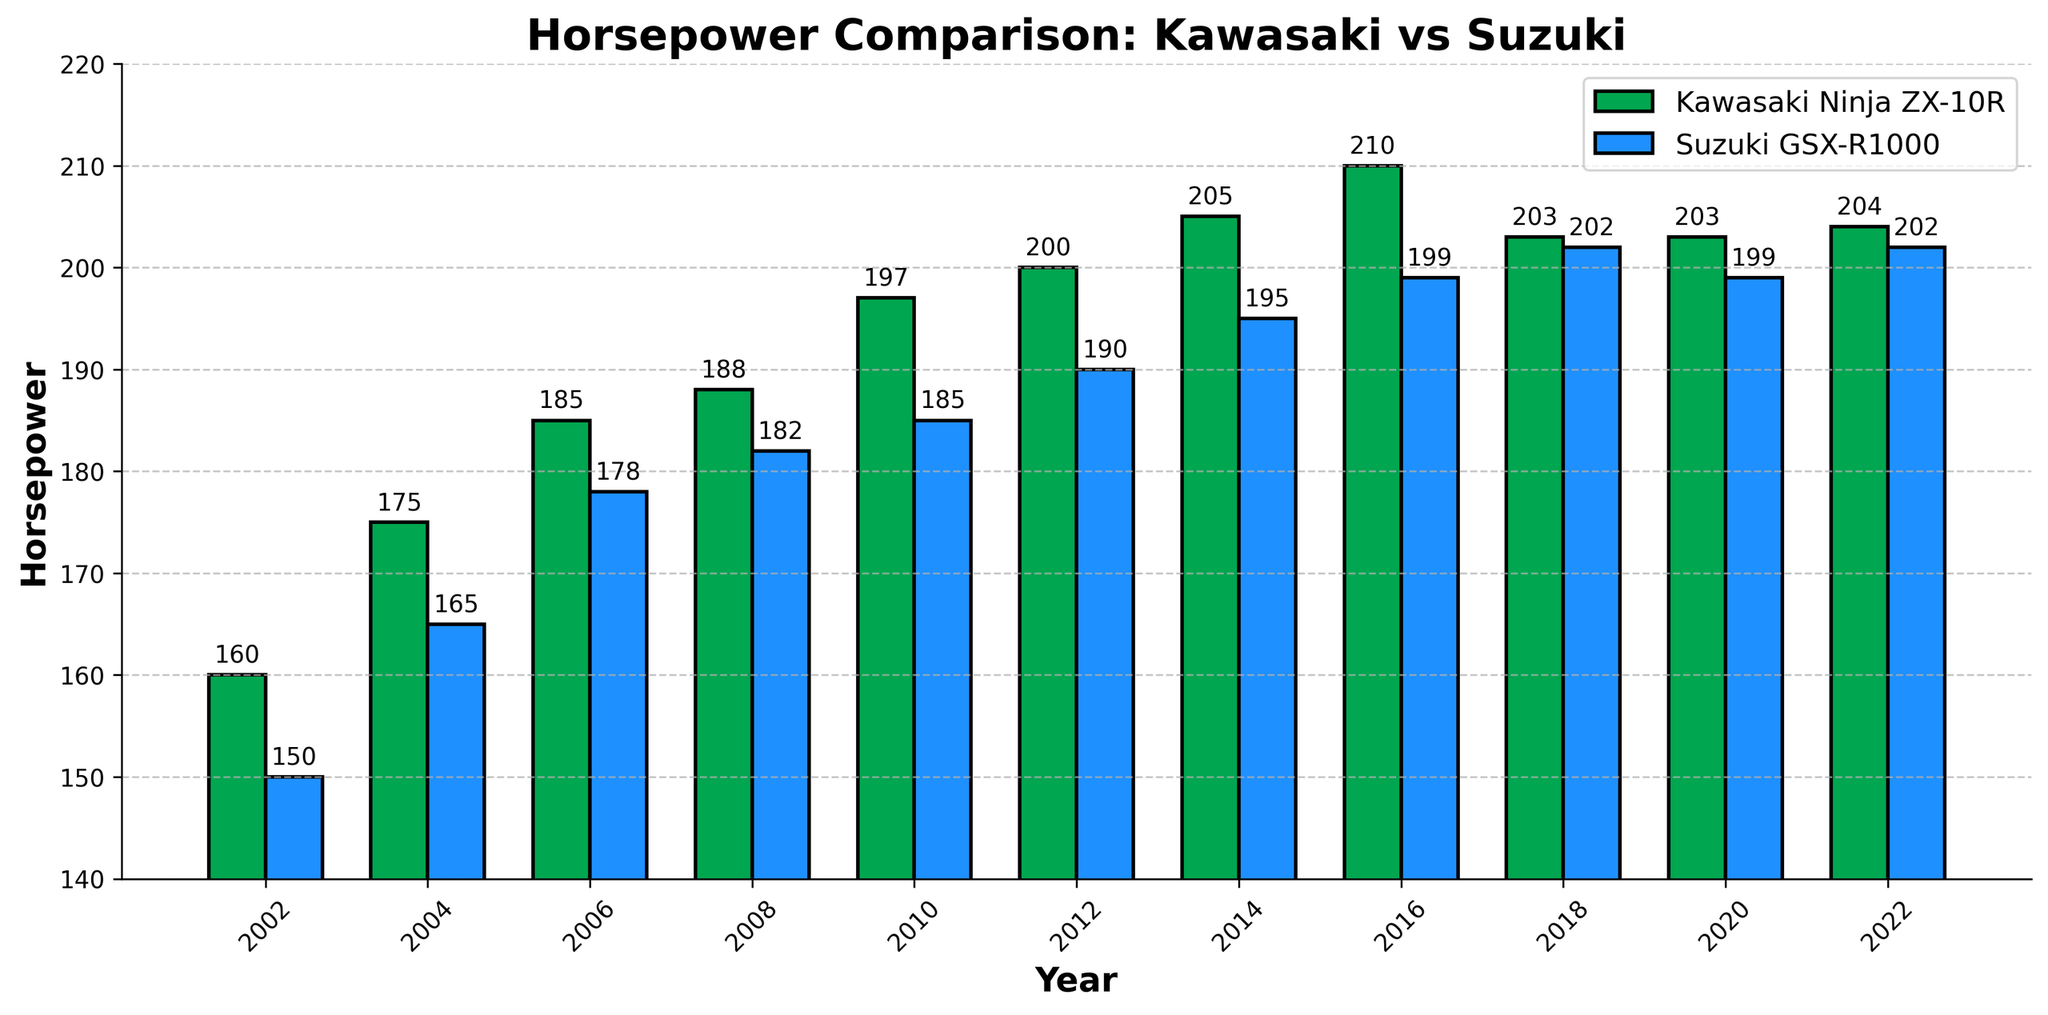How does the horsepower of the Kawasaki Ninja ZX-10R in 2010 compare to the Suzuki GSX-R1000 in the same year? Look at the bars for the year 2010. The Kawasaki bar is taller at 197 hp, while the Suzuki bar is at 185 hp.
Answer: The Kawasaki Ninja ZX-10R has 12 more horsepower Which year shows the smallest difference in horsepower between the Kawasaki Ninja ZX-10R and the Suzuki GSX-R1000? Check the lengths of the bars in each year and identify the smallest gap. In 2018, Kawasaki has 203 hp and Suzuki has 202 hp, which is the smallest difference.
Answer: 2018 In which year did Kawasaki first surpass 200 horsepower? Look at the Kawasaki bars and find the first year where the value exceeds 200. This happens in 2012 where it reaches 200 hp.
Answer: 2012 What is the average horsepower of the Suzuki GSX-R1000 over the 20 years shown? Add up all horsepower values for Suzuki from 2002 to 2022, then divide by the number of years (11). Sum = 150 + 165 + 178 + 182 + 185 + 190 + 195 + 199 + 202 + 199 + 202 = 2049. Average = 2049 / 11.
Answer: 186.3 Which model has the highest horsepower recorded in the entire 20 years? Identify the tallest bar in the entire chart. It's the Kawasaki Ninja ZX-10R in 2016 with 210 hp.
Answer: Kawasaki Ninja ZX-10R Between which consecutive years did the Kawasaki Ninja ZX-10R show the largest increase in horsepower? Calculate the year-over-year differences in horsepower for Kawasaki. The largest increase is between 2002 and 2004 (175 - 160 = 15 hp).
Answer: 2002 to 2004 How many years did the Suzuki GSX-R1000 have higher horsepower than the Kawasaki Ninja ZX-10R? Compare the heights of the bars for each year. Suzuki had higher horsepower in 2018 and 2022.
Answer: 2 years What is the total horsepower increase for Kawasaki Ninja ZX-10R from 2002 to 2022? Subtract the 2002 value from the 2022 value. Kawasaki in 2002 is 160 hp and in 2022 it is 204 hp. Increase = 204 - 160.
Answer: 44 hp What is the horsepower range for the Suzuki GSX-R1000 between 2002 and 2022? Identify the maximum and minimum values for Suzuki between these years. The minimum is 150 hp in 2002 and the maximum is 202 hp in 2018 and 2022. Range = 202 - 150.
Answer: 52 hp 